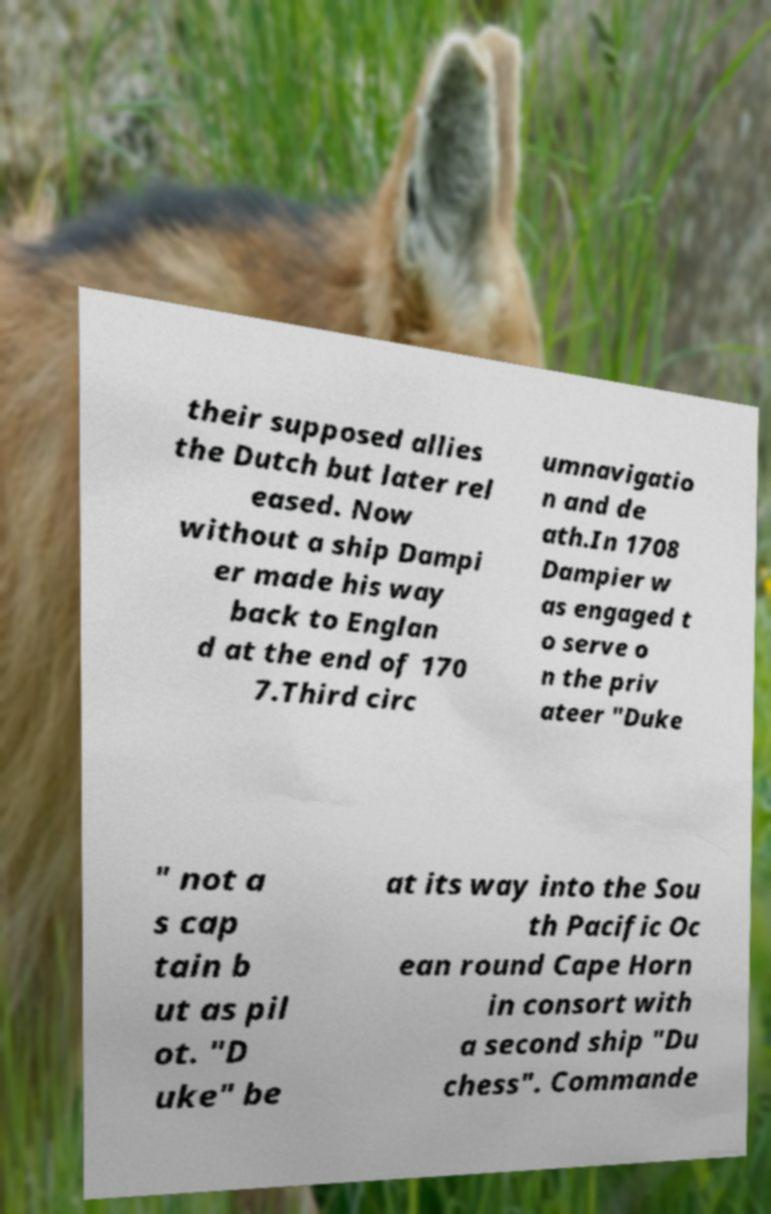Please identify and transcribe the text found in this image. their supposed allies the Dutch but later rel eased. Now without a ship Dampi er made his way back to Englan d at the end of 170 7.Third circ umnavigatio n and de ath.In 1708 Dampier w as engaged t o serve o n the priv ateer "Duke " not a s cap tain b ut as pil ot. "D uke" be at its way into the Sou th Pacific Oc ean round Cape Horn in consort with a second ship "Du chess". Commande 